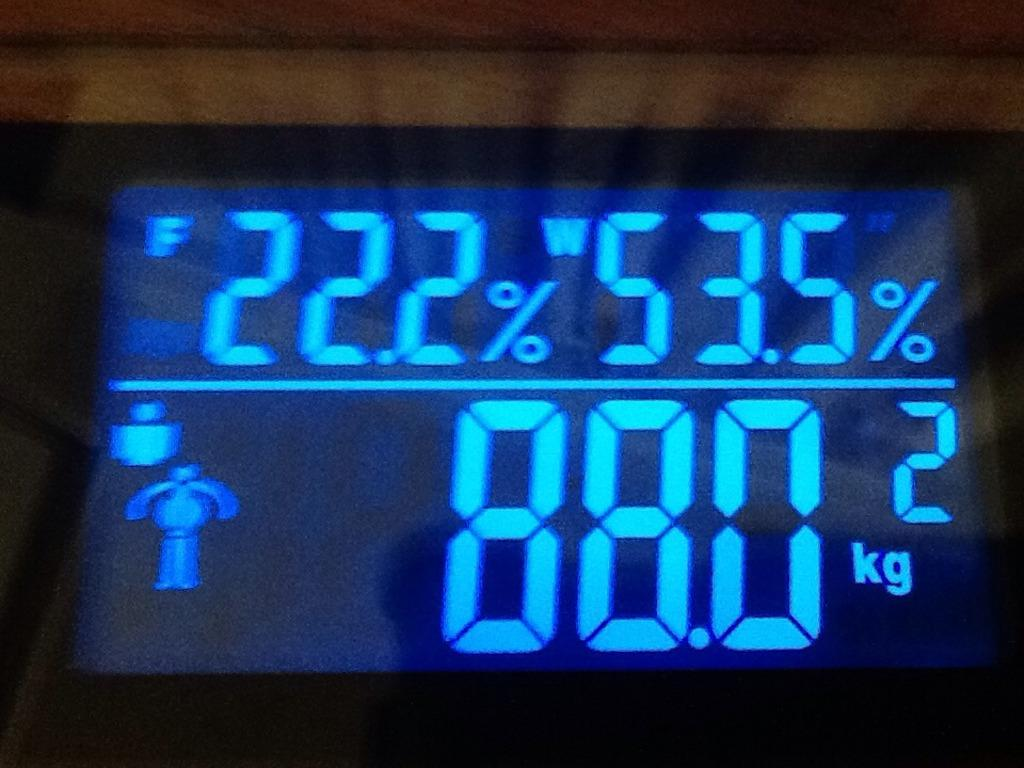<image>
Create a compact narrative representing the image presented. A digital display shows a weight of 88.0 kilograms. 